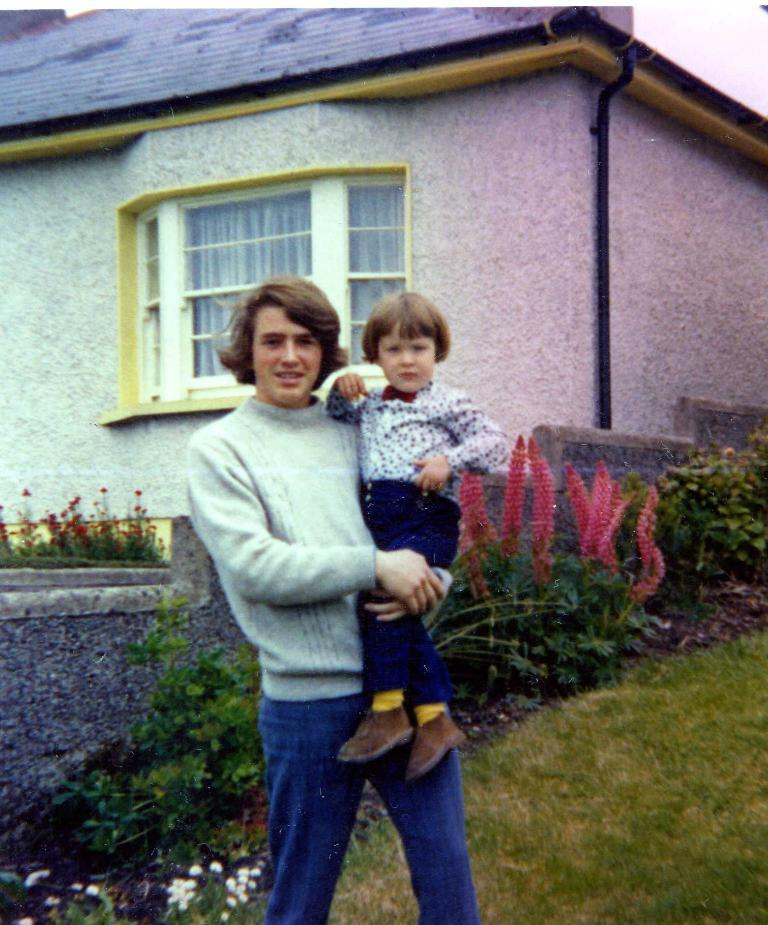What is the person in the image doing? The person is carrying a kid in the image. What can be seen in the background of the image? There are plants, grass, flowers, a wall, a house, glass windows, curtains, and pipes in the background of the image. What type of nail is being used to measure the activity in the image? There is no nail or activity being measured in the image; it features a person carrying a kid with various background elements. 